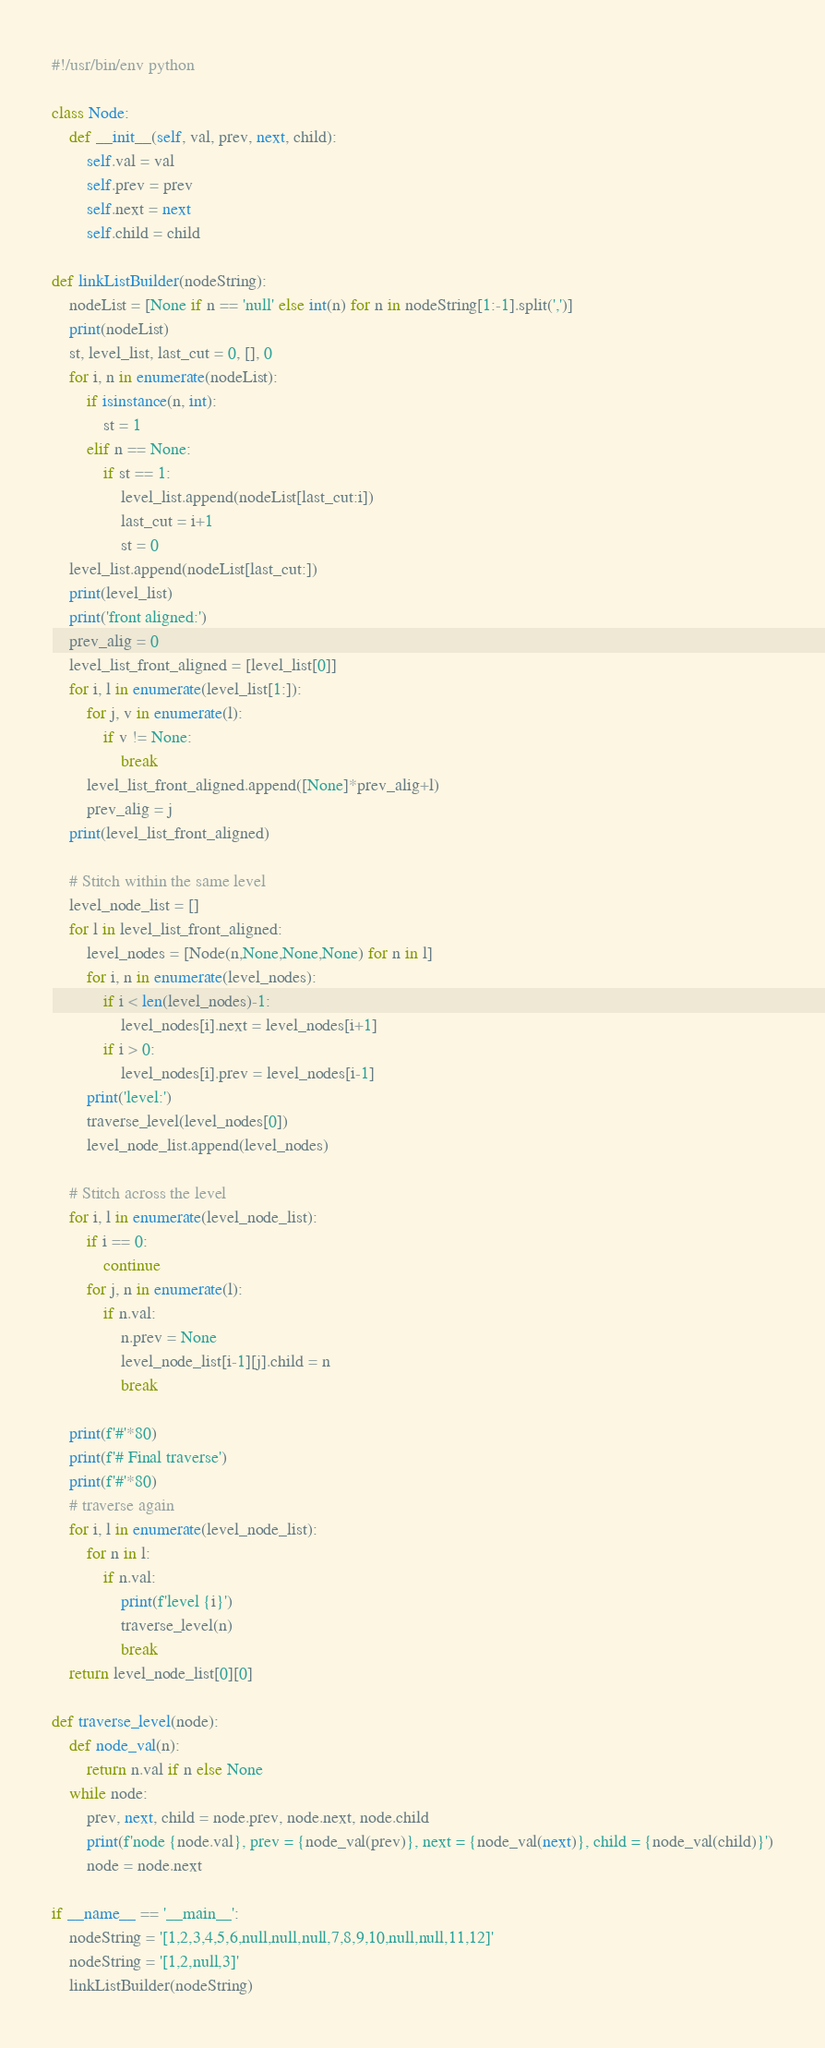Convert code to text. <code><loc_0><loc_0><loc_500><loc_500><_Python_>#!/usr/bin/env python

class Node:
    def __init__(self, val, prev, next, child):
        self.val = val
        self.prev = prev
        self.next = next
        self.child = child

def linkListBuilder(nodeString):
    nodeList = [None if n == 'null' else int(n) for n in nodeString[1:-1].split(',')]
    print(nodeList)
    st, level_list, last_cut = 0, [], 0
    for i, n in enumerate(nodeList):
        if isinstance(n, int):
            st = 1
        elif n == None:
            if st == 1:
                level_list.append(nodeList[last_cut:i])
                last_cut = i+1
                st = 0
    level_list.append(nodeList[last_cut:])
    print(level_list)
    print('front aligned:')
    prev_alig = 0
    level_list_front_aligned = [level_list[0]]
    for i, l in enumerate(level_list[1:]):
        for j, v in enumerate(l):
            if v != None:
                break
        level_list_front_aligned.append([None]*prev_alig+l)
        prev_alig = j
    print(level_list_front_aligned)

    # Stitch within the same level
    level_node_list = []
    for l in level_list_front_aligned:
        level_nodes = [Node(n,None,None,None) for n in l]
        for i, n in enumerate(level_nodes):
            if i < len(level_nodes)-1:
                level_nodes[i].next = level_nodes[i+1]
            if i > 0:
                level_nodes[i].prev = level_nodes[i-1]
        print('level:')
        traverse_level(level_nodes[0])
        level_node_list.append(level_nodes)

    # Stitch across the level
    for i, l in enumerate(level_node_list):
        if i == 0:
            continue
        for j, n in enumerate(l):
            if n.val:
                n.prev = None
                level_node_list[i-1][j].child = n
                break

    print(f'#'*80)
    print(f'# Final traverse')
    print(f'#'*80)
    # traverse again
    for i, l in enumerate(level_node_list):
        for n in l:
            if n.val:
                print(f'level {i}')
                traverse_level(n)
                break
    return level_node_list[0][0]

def traverse_level(node):
    def node_val(n):
        return n.val if n else None
    while node:
        prev, next, child = node.prev, node.next, node.child
        print(f'node {node.val}, prev = {node_val(prev)}, next = {node_val(next)}, child = {node_val(child)}')
        node = node.next

if __name__ == '__main__':
    nodeString = '[1,2,3,4,5,6,null,null,null,7,8,9,10,null,null,11,12]'
    nodeString = '[1,2,null,3]'
    linkListBuilder(nodeString)
</code> 